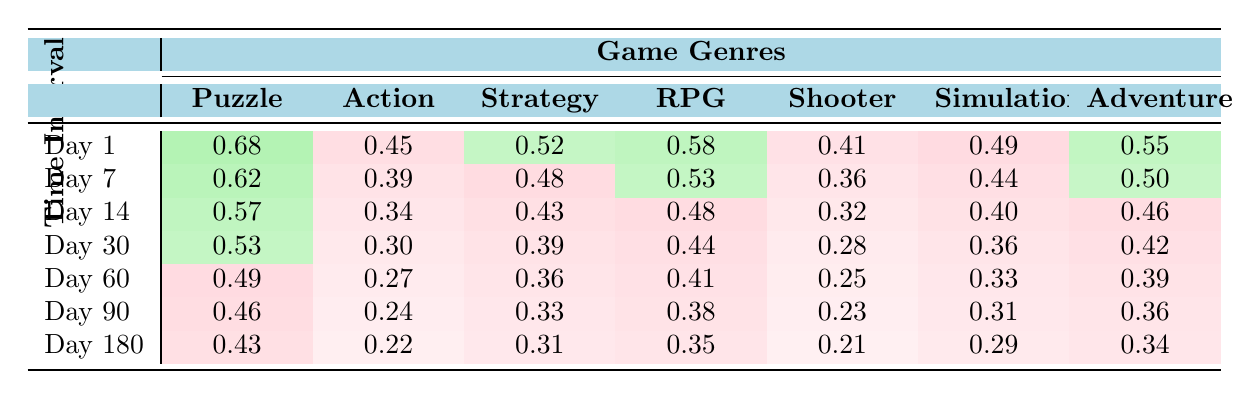What is the retention rate for Puzzle games on Day 1? The column for Day 1 under the Puzzle genre shows a retention rate of 0.68, which is listed directly in the table.
Answer: 0.68 Which game genre has the lowest retention rate on Day 30? Looking at the Day 30 row, the Shooter genre has the lowest retention rate of 0.28, which is presented in the table.
Answer: Shooter What is the average retention rate for RPG games across all time intervals? To find the average for RPG games, sum the values (0.58 + 0.53 + 0.48 + 0.44 + 0.41 + 0.38 + 0.35) and divide by the number of time intervals (7). The sum equals 3.17 and the average is 3.17 / 7 = 0.453.
Answer: 0.453 Is the retention rate for Action games higher than that for Simulation games on Day 14? On Day 14, Action games have a retention rate of 0.43 while Simulation games have a rate of 0.40. Since 0.43 is greater than 0.40, the statement is true.
Answer: Yes What is the difference in retention rates between Day 1 and Day 7 for Adventure games? The retention rate on Day 1 for Adventure games is 0.55, while on Day 7 it is 0.50. The difference is 0.55 - 0.50 = 0.05.
Answer: 0.05 Which genre shows the largest decline in retention rate from Day 1 to Day 180? The retention rate for Day 1 and Day 180 for each genre is calculated to find the declines: Puzzle (0.68 - 0.43 = 0.25), Action (0.62 - 0.22 = 0.40), Strategy (0.57 - 0.31 = 0.26), RPG (0.53 - 0.35 = 0.18), Shooter (0.49 - 0.21 = 0.28), Simulation (0.46 - 0.29 = 0.17), Adventure (0.43 - 0.34 = 0.09). The largest decline is in the Action genre (0.40).
Answer: Action What are the retention rates for the Simulation genre across the first three time intervals? The rates are 0.49 for Day 1, 0.44 for Day 7, and 0.40 for Day 14. This is a direct retrieval from the table.
Answer: 0.49, 0.44, 0.40 Is the retention rate for the Adventure genre on Day 60 higher than for Puzzle games on Day 90? For Adventure games on Day 60, the rate is 0.39, and for Puzzle games on Day 90, it is 0.46. Hence, 0.39 is not higher than 0.46, making the statement false.
Answer: No What is the median retention rate for all genres on Day 14? The retention rates for Day 14 are 0.57, 0.34, 0.43, 0.48, 0.32, 0.40, 0.46. Arranging them gives us 0.32, 0.34, 0.40, 0.43, 0.46, 0.48, 0.57. The median is the middle value, which is 0.43 (the fourth value).
Answer: 0.43 